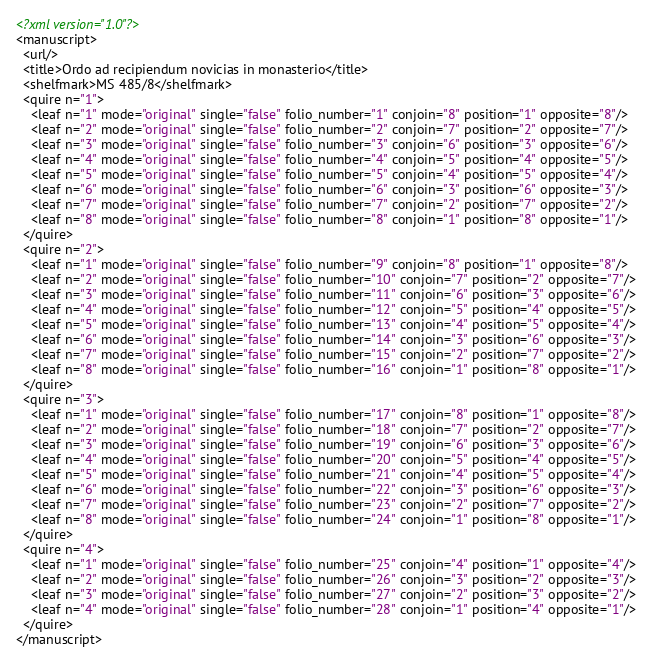<code> <loc_0><loc_0><loc_500><loc_500><_XML_><?xml version="1.0"?>
<manuscript>
  <url/>
  <title>Ordo ad recipiendum novicias in monasterio</title>
  <shelfmark>MS 485/8</shelfmark>
  <quire n="1">
    <leaf n="1" mode="original" single="false" folio_number="1" conjoin="8" position="1" opposite="8"/>
    <leaf n="2" mode="original" single="false" folio_number="2" conjoin="7" position="2" opposite="7"/>
    <leaf n="3" mode="original" single="false" folio_number="3" conjoin="6" position="3" opposite="6"/>
    <leaf n="4" mode="original" single="false" folio_number="4" conjoin="5" position="4" opposite="5"/>
    <leaf n="5" mode="original" single="false" folio_number="5" conjoin="4" position="5" opposite="4"/>
    <leaf n="6" mode="original" single="false" folio_number="6" conjoin="3" position="6" opposite="3"/>
    <leaf n="7" mode="original" single="false" folio_number="7" conjoin="2" position="7" opposite="2"/>
    <leaf n="8" mode="original" single="false" folio_number="8" conjoin="1" position="8" opposite="1"/>
  </quire>
  <quire n="2">
    <leaf n="1" mode="original" single="false" folio_number="9" conjoin="8" position="1" opposite="8"/>
    <leaf n="2" mode="original" single="false" folio_number="10" conjoin="7" position="2" opposite="7"/>
    <leaf n="3" mode="original" single="false" folio_number="11" conjoin="6" position="3" opposite="6"/>
    <leaf n="4" mode="original" single="false" folio_number="12" conjoin="5" position="4" opposite="5"/>
    <leaf n="5" mode="original" single="false" folio_number="13" conjoin="4" position="5" opposite="4"/>
    <leaf n="6" mode="original" single="false" folio_number="14" conjoin="3" position="6" opposite="3"/>
    <leaf n="7" mode="original" single="false" folio_number="15" conjoin="2" position="7" opposite="2"/>
    <leaf n="8" mode="original" single="false" folio_number="16" conjoin="1" position="8" opposite="1"/>
  </quire>
  <quire n="3">
    <leaf n="1" mode="original" single="false" folio_number="17" conjoin="8" position="1" opposite="8"/>
    <leaf n="2" mode="original" single="false" folio_number="18" conjoin="7" position="2" opposite="7"/>
    <leaf n="3" mode="original" single="false" folio_number="19" conjoin="6" position="3" opposite="6"/>
    <leaf n="4" mode="original" single="false" folio_number="20" conjoin="5" position="4" opposite="5"/>
    <leaf n="5" mode="original" single="false" folio_number="21" conjoin="4" position="5" opposite="4"/>
    <leaf n="6" mode="original" single="false" folio_number="22" conjoin="3" position="6" opposite="3"/>
    <leaf n="7" mode="original" single="false" folio_number="23" conjoin="2" position="7" opposite="2"/>
    <leaf n="8" mode="original" single="false" folio_number="24" conjoin="1" position="8" opposite="1"/>
  </quire>
  <quire n="4">
    <leaf n="1" mode="original" single="false" folio_number="25" conjoin="4" position="1" opposite="4"/>
    <leaf n="2" mode="original" single="false" folio_number="26" conjoin="3" position="2" opposite="3"/>
    <leaf n="3" mode="original" single="false" folio_number="27" conjoin="2" position="3" opposite="2"/>
    <leaf n="4" mode="original" single="false" folio_number="28" conjoin="1" position="4" opposite="1"/>
  </quire>
</manuscript>
</code> 